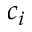Convert formula to latex. <formula><loc_0><loc_0><loc_500><loc_500>c _ { i }</formula> 